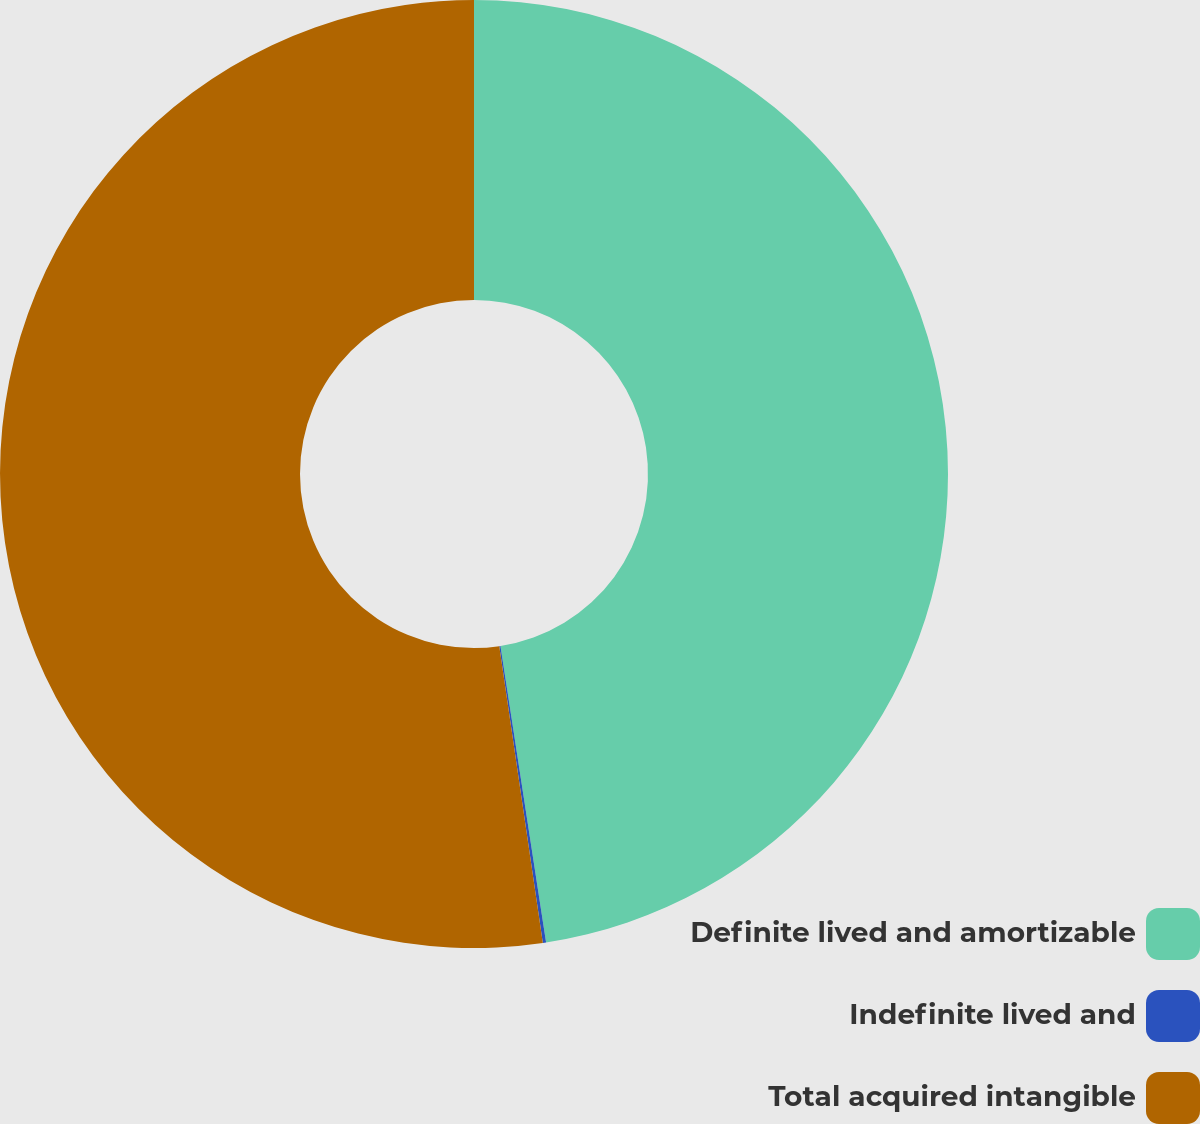Convert chart to OTSL. <chart><loc_0><loc_0><loc_500><loc_500><pie_chart><fcel>Definite lived and amortizable<fcel>Indefinite lived and<fcel>Total acquired intangible<nl><fcel>47.57%<fcel>0.11%<fcel>52.32%<nl></chart> 